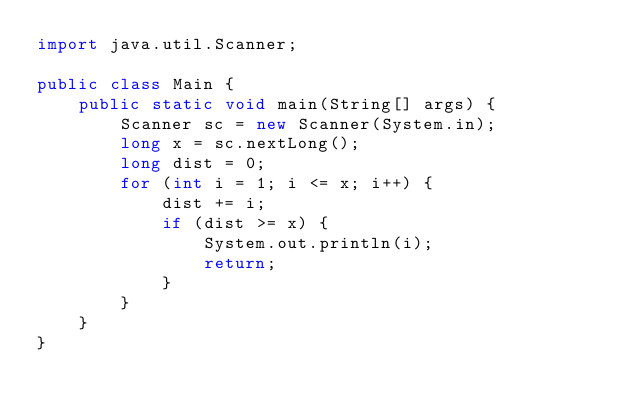<code> <loc_0><loc_0><loc_500><loc_500><_Java_>import java.util.Scanner;

public class Main {
    public static void main(String[] args) {
        Scanner sc = new Scanner(System.in);
        long x = sc.nextLong();
        long dist = 0;
        for (int i = 1; i <= x; i++) {
            dist += i;
            if (dist >= x) {
                System.out.println(i);
                return;
            }
        }
    }
}
</code> 